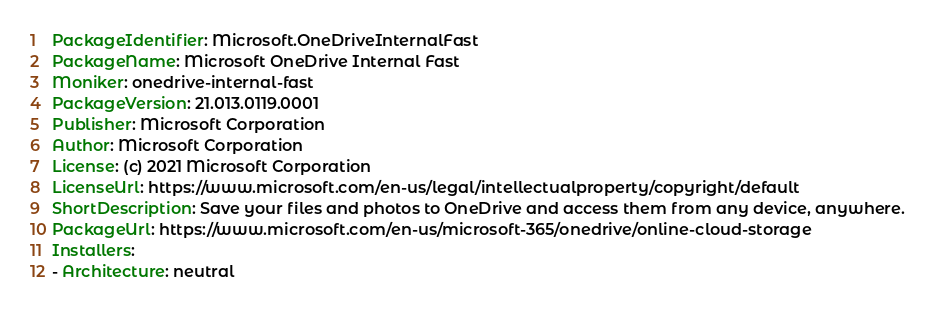<code> <loc_0><loc_0><loc_500><loc_500><_YAML_>PackageIdentifier: Microsoft.OneDriveInternalFast
PackageName: Microsoft OneDrive Internal Fast
Moniker: onedrive-internal-fast
PackageVersion: 21.013.0119.0001
Publisher: Microsoft Corporation
Author: Microsoft Corporation
License: (c) 2021 Microsoft Corporation
LicenseUrl: https://www.microsoft.com/en-us/legal/intellectualproperty/copyright/default
ShortDescription: Save your files and photos to OneDrive and access them from any device, anywhere.
PackageUrl: https://www.microsoft.com/en-us/microsoft-365/onedrive/online-cloud-storage
Installers:
- Architecture: neutral</code> 